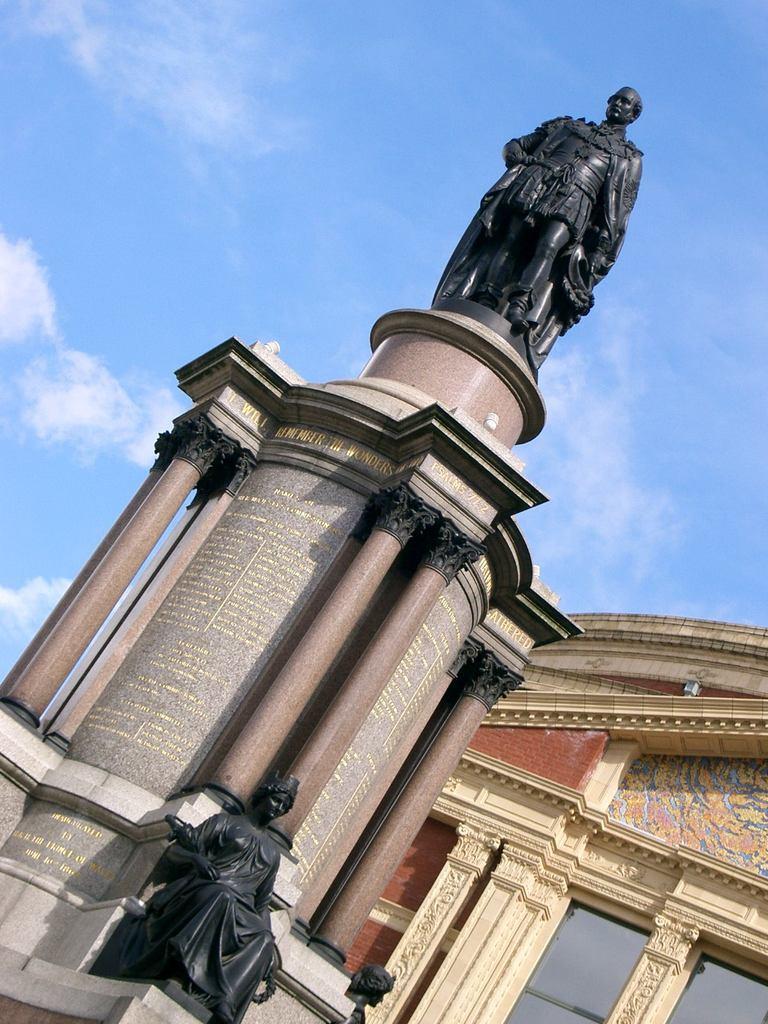Can you describe this image briefly? Sky is in blue color. Here we can see sculptures and building with glass windows. 